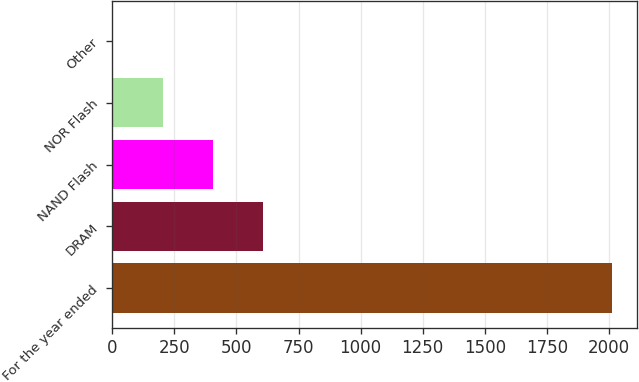<chart> <loc_0><loc_0><loc_500><loc_500><bar_chart><fcel>For the year ended<fcel>DRAM<fcel>NAND Flash<fcel>NOR Flash<fcel>Other<nl><fcel>2014<fcel>605.6<fcel>404.4<fcel>203.2<fcel>2<nl></chart> 